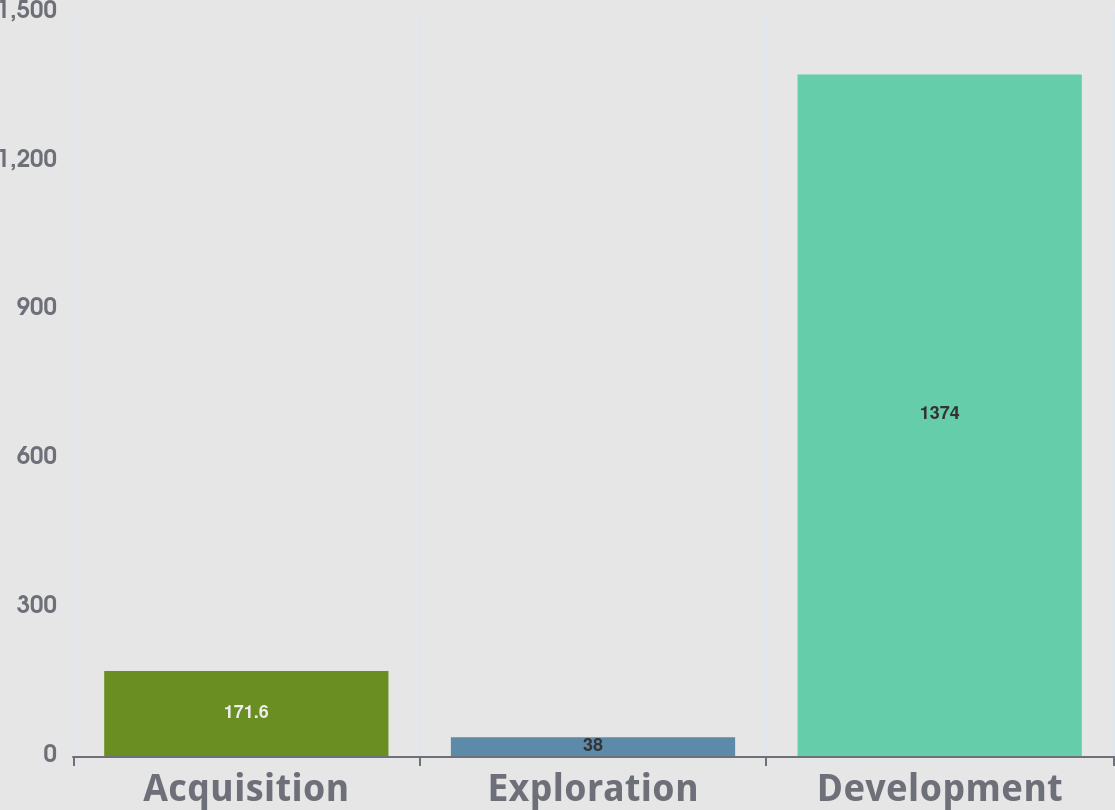Convert chart to OTSL. <chart><loc_0><loc_0><loc_500><loc_500><bar_chart><fcel>Acquisition<fcel>Exploration<fcel>Development<nl><fcel>171.6<fcel>38<fcel>1374<nl></chart> 